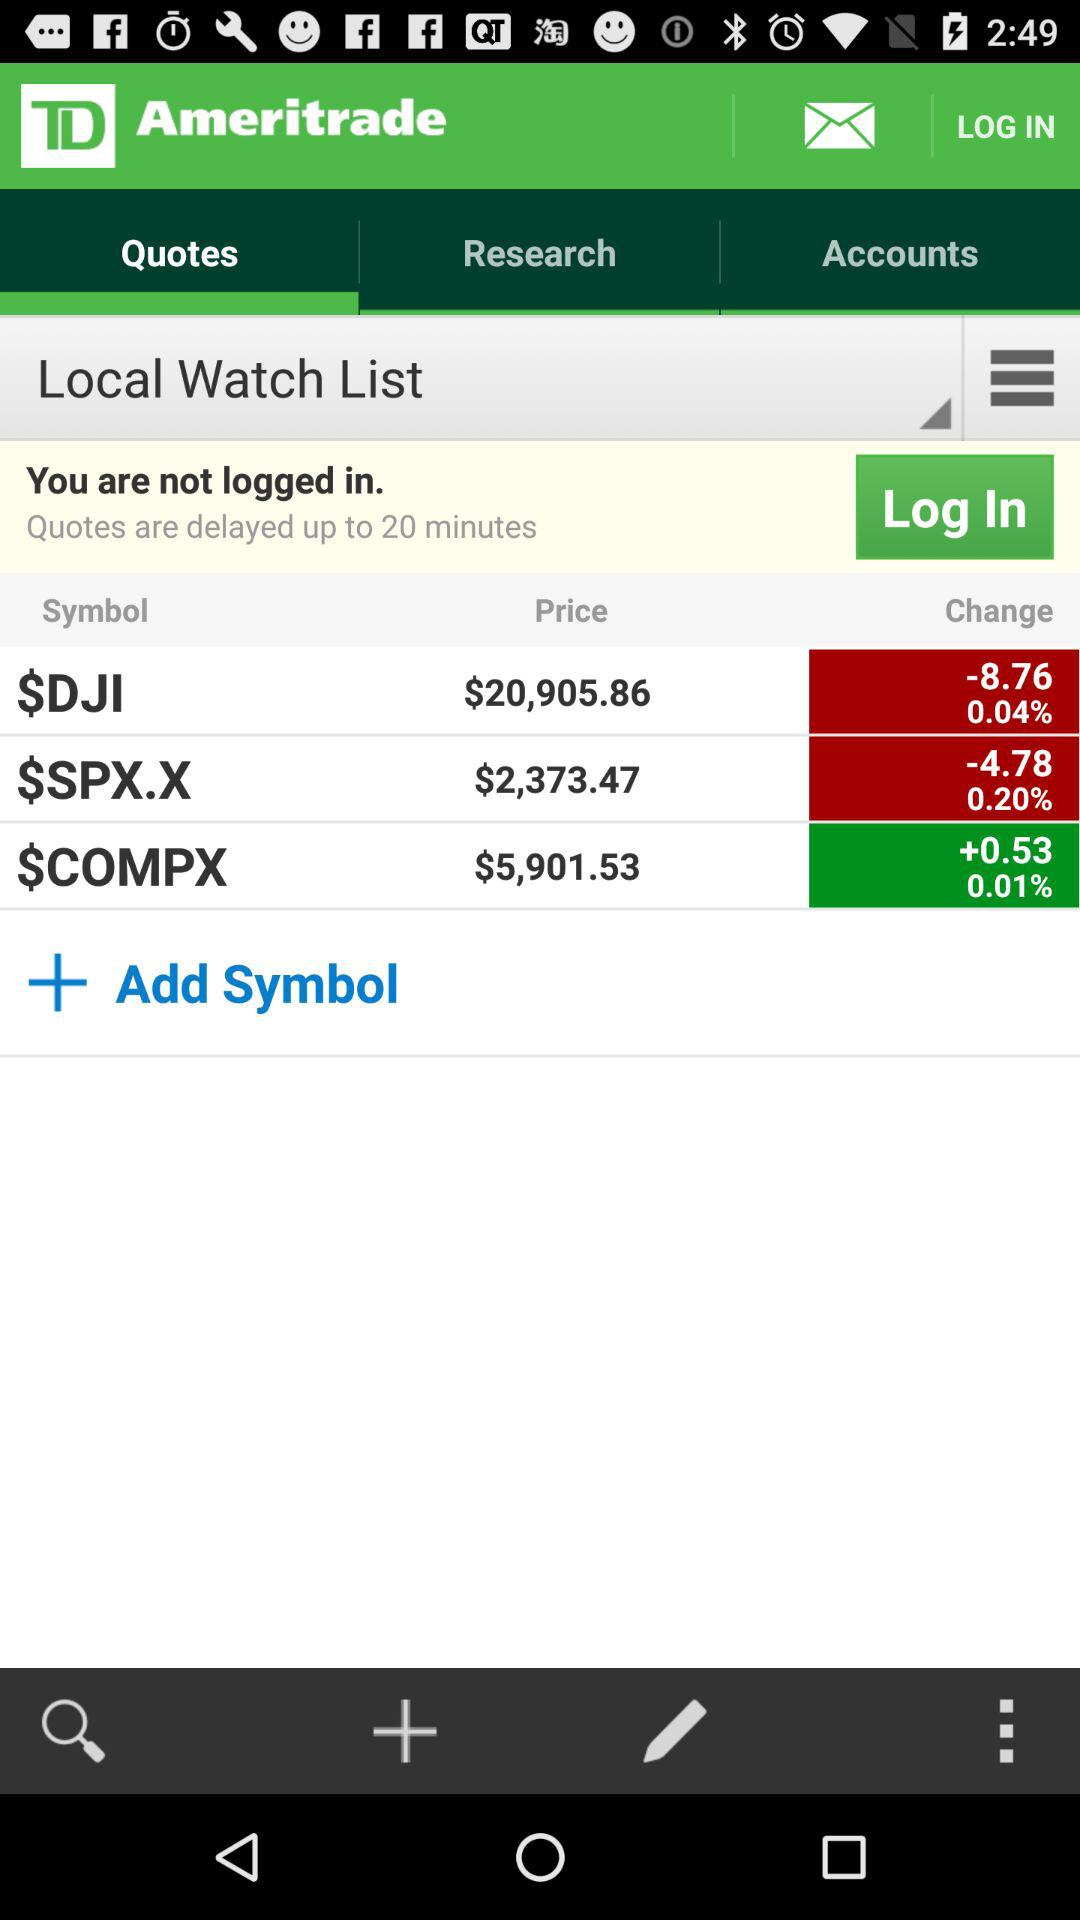Which tab is open? The open tab is "Quotes". 